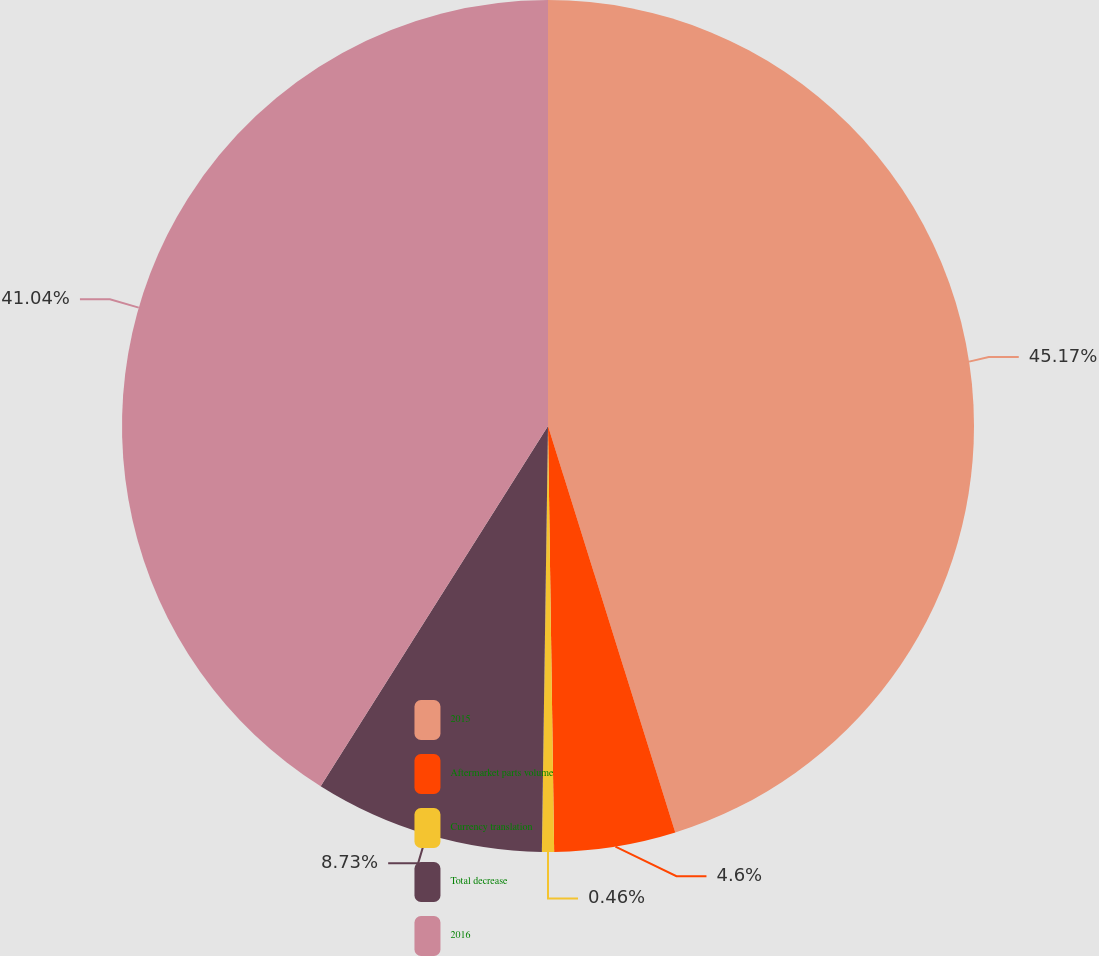Convert chart. <chart><loc_0><loc_0><loc_500><loc_500><pie_chart><fcel>2015<fcel>Aftermarket parts volume<fcel>Currency translation<fcel>Total decrease<fcel>2016<nl><fcel>45.17%<fcel>4.6%<fcel>0.46%<fcel>8.73%<fcel>41.04%<nl></chart> 